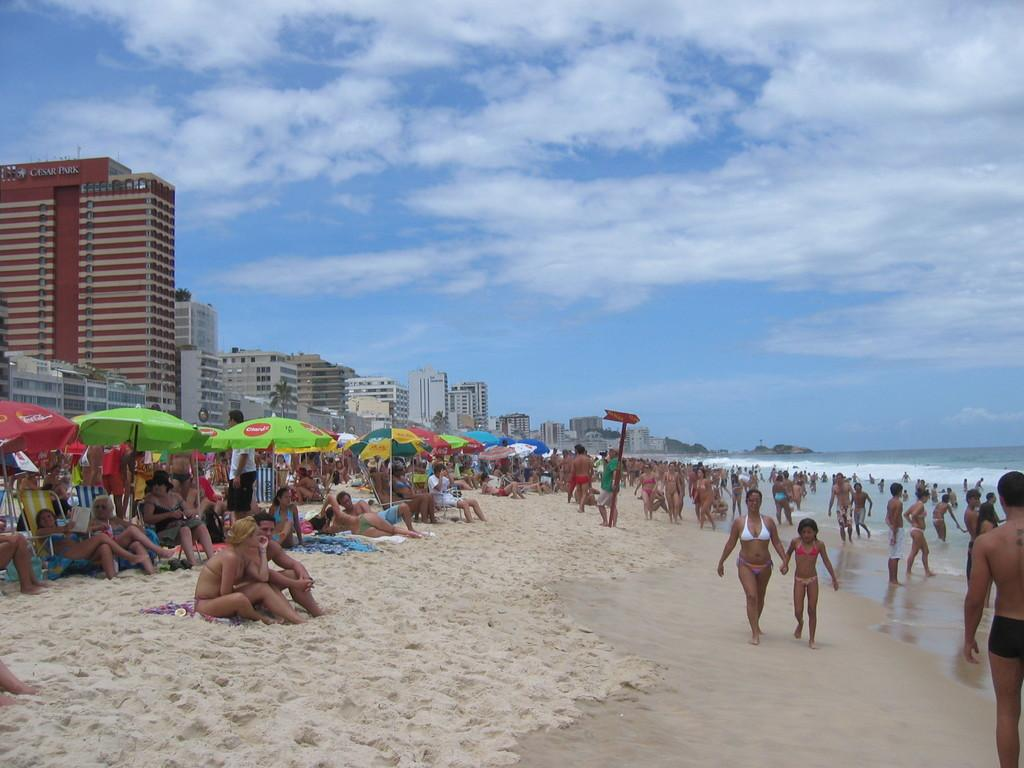How many people are in the image? There are people in the image, but the exact number is not specified. What is the primary natural element visible in the image? Water is visible in the image. What do the umbrellas in the image suggest? The presence of umbrellas suggests that it might be raining or that there is a possibility of rain. What can be seen on the signboard in the image? The information on the signboard is not specified in the facts provided. What type of vegetation is visible in the image? Trees are visible in the image. What type of structures are present in the image? Buildings are present in the image. How would you describe the weather based on the image? The sky is cloudy in the image. What are some people doing in the image? Some people are sitting on chairs. What type of picture is hanging on the wall in the image? There is no mention of a picture hanging on the wall in the image. Can you see steam coming from the water in the image? There is no mention of steam coming from the water in the image. 